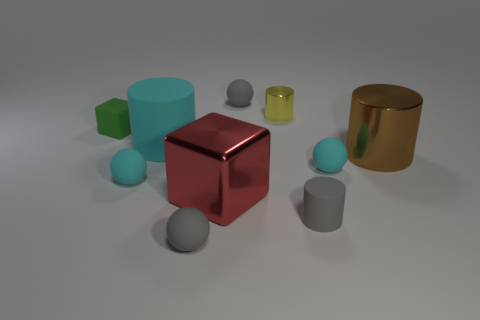Are there any gray rubber cylinders to the right of the brown object?
Offer a very short reply. No. There is a metal cylinder that is behind the small green object; are there any small cubes right of it?
Your response must be concise. No. Is the number of cyan matte balls left of the cyan matte cylinder the same as the number of tiny green cubes that are left of the green matte object?
Provide a short and direct response. No. What is the color of the large cube that is the same material as the big brown cylinder?
Your response must be concise. Red. Are there any cylinders that have the same material as the tiny block?
Your response must be concise. Yes. What number of things are small yellow cubes or yellow metal objects?
Ensure brevity in your answer.  1. Does the cyan cylinder have the same material as the gray ball that is left of the large red object?
Your response must be concise. Yes. What size is the green thing to the left of the large brown thing?
Keep it short and to the point. Small. Is the number of big cyan matte objects less than the number of rubber cylinders?
Keep it short and to the point. Yes. Is there a large shiny object of the same color as the tiny metallic thing?
Your response must be concise. No. 